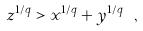<formula> <loc_0><loc_0><loc_500><loc_500>z ^ { 1 / q } > x ^ { 1 / q } + y ^ { 1 / q } \ ,</formula> 